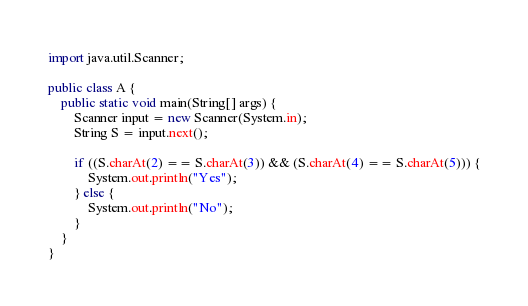<code> <loc_0><loc_0><loc_500><loc_500><_Java_>import java.util.Scanner;

public class A {
    public static void main(String[] args) {
        Scanner input = new Scanner(System.in);
        String S = input.next();

        if ((S.charAt(2) == S.charAt(3)) && (S.charAt(4) == S.charAt(5))) {
            System.out.println("Yes");
        } else {
            System.out.println("No");
        }
    }
}
</code> 